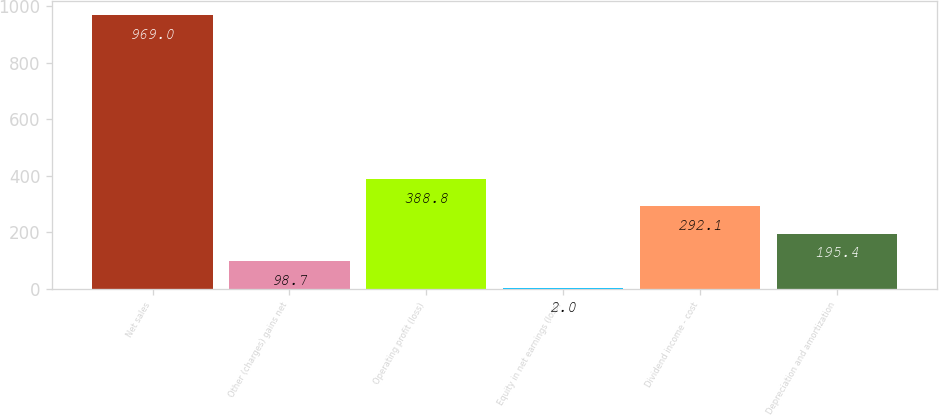Convert chart to OTSL. <chart><loc_0><loc_0><loc_500><loc_500><bar_chart><fcel>Net sales<fcel>Other (charges) gains net<fcel>Operating profit (loss)<fcel>Equity in net earnings (loss)<fcel>Dividend income - cost<fcel>Depreciation and amortization<nl><fcel>969<fcel>98.7<fcel>388.8<fcel>2<fcel>292.1<fcel>195.4<nl></chart> 